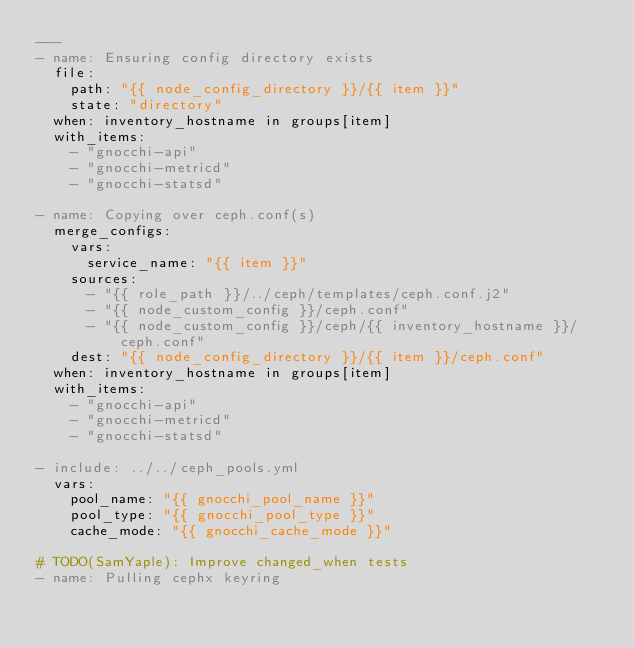Convert code to text. <code><loc_0><loc_0><loc_500><loc_500><_YAML_>---
- name: Ensuring config directory exists
  file:
    path: "{{ node_config_directory }}/{{ item }}"
    state: "directory"
  when: inventory_hostname in groups[item]
  with_items:
    - "gnocchi-api"
    - "gnocchi-metricd"
    - "gnocchi-statsd"

- name: Copying over ceph.conf(s)
  merge_configs:
    vars:
      service_name: "{{ item }}"
    sources:
      - "{{ role_path }}/../ceph/templates/ceph.conf.j2"
      - "{{ node_custom_config }}/ceph.conf"
      - "{{ node_custom_config }}/ceph/{{ inventory_hostname }}/ceph.conf"
    dest: "{{ node_config_directory }}/{{ item }}/ceph.conf"
  when: inventory_hostname in groups[item]
  with_items:
    - "gnocchi-api"
    - "gnocchi-metricd"
    - "gnocchi-statsd"

- include: ../../ceph_pools.yml
  vars:
    pool_name: "{{ gnocchi_pool_name }}"
    pool_type: "{{ gnocchi_pool_type }}"
    cache_mode: "{{ gnocchi_cache_mode }}"

# TODO(SamYaple): Improve changed_when tests
- name: Pulling cephx keyring</code> 